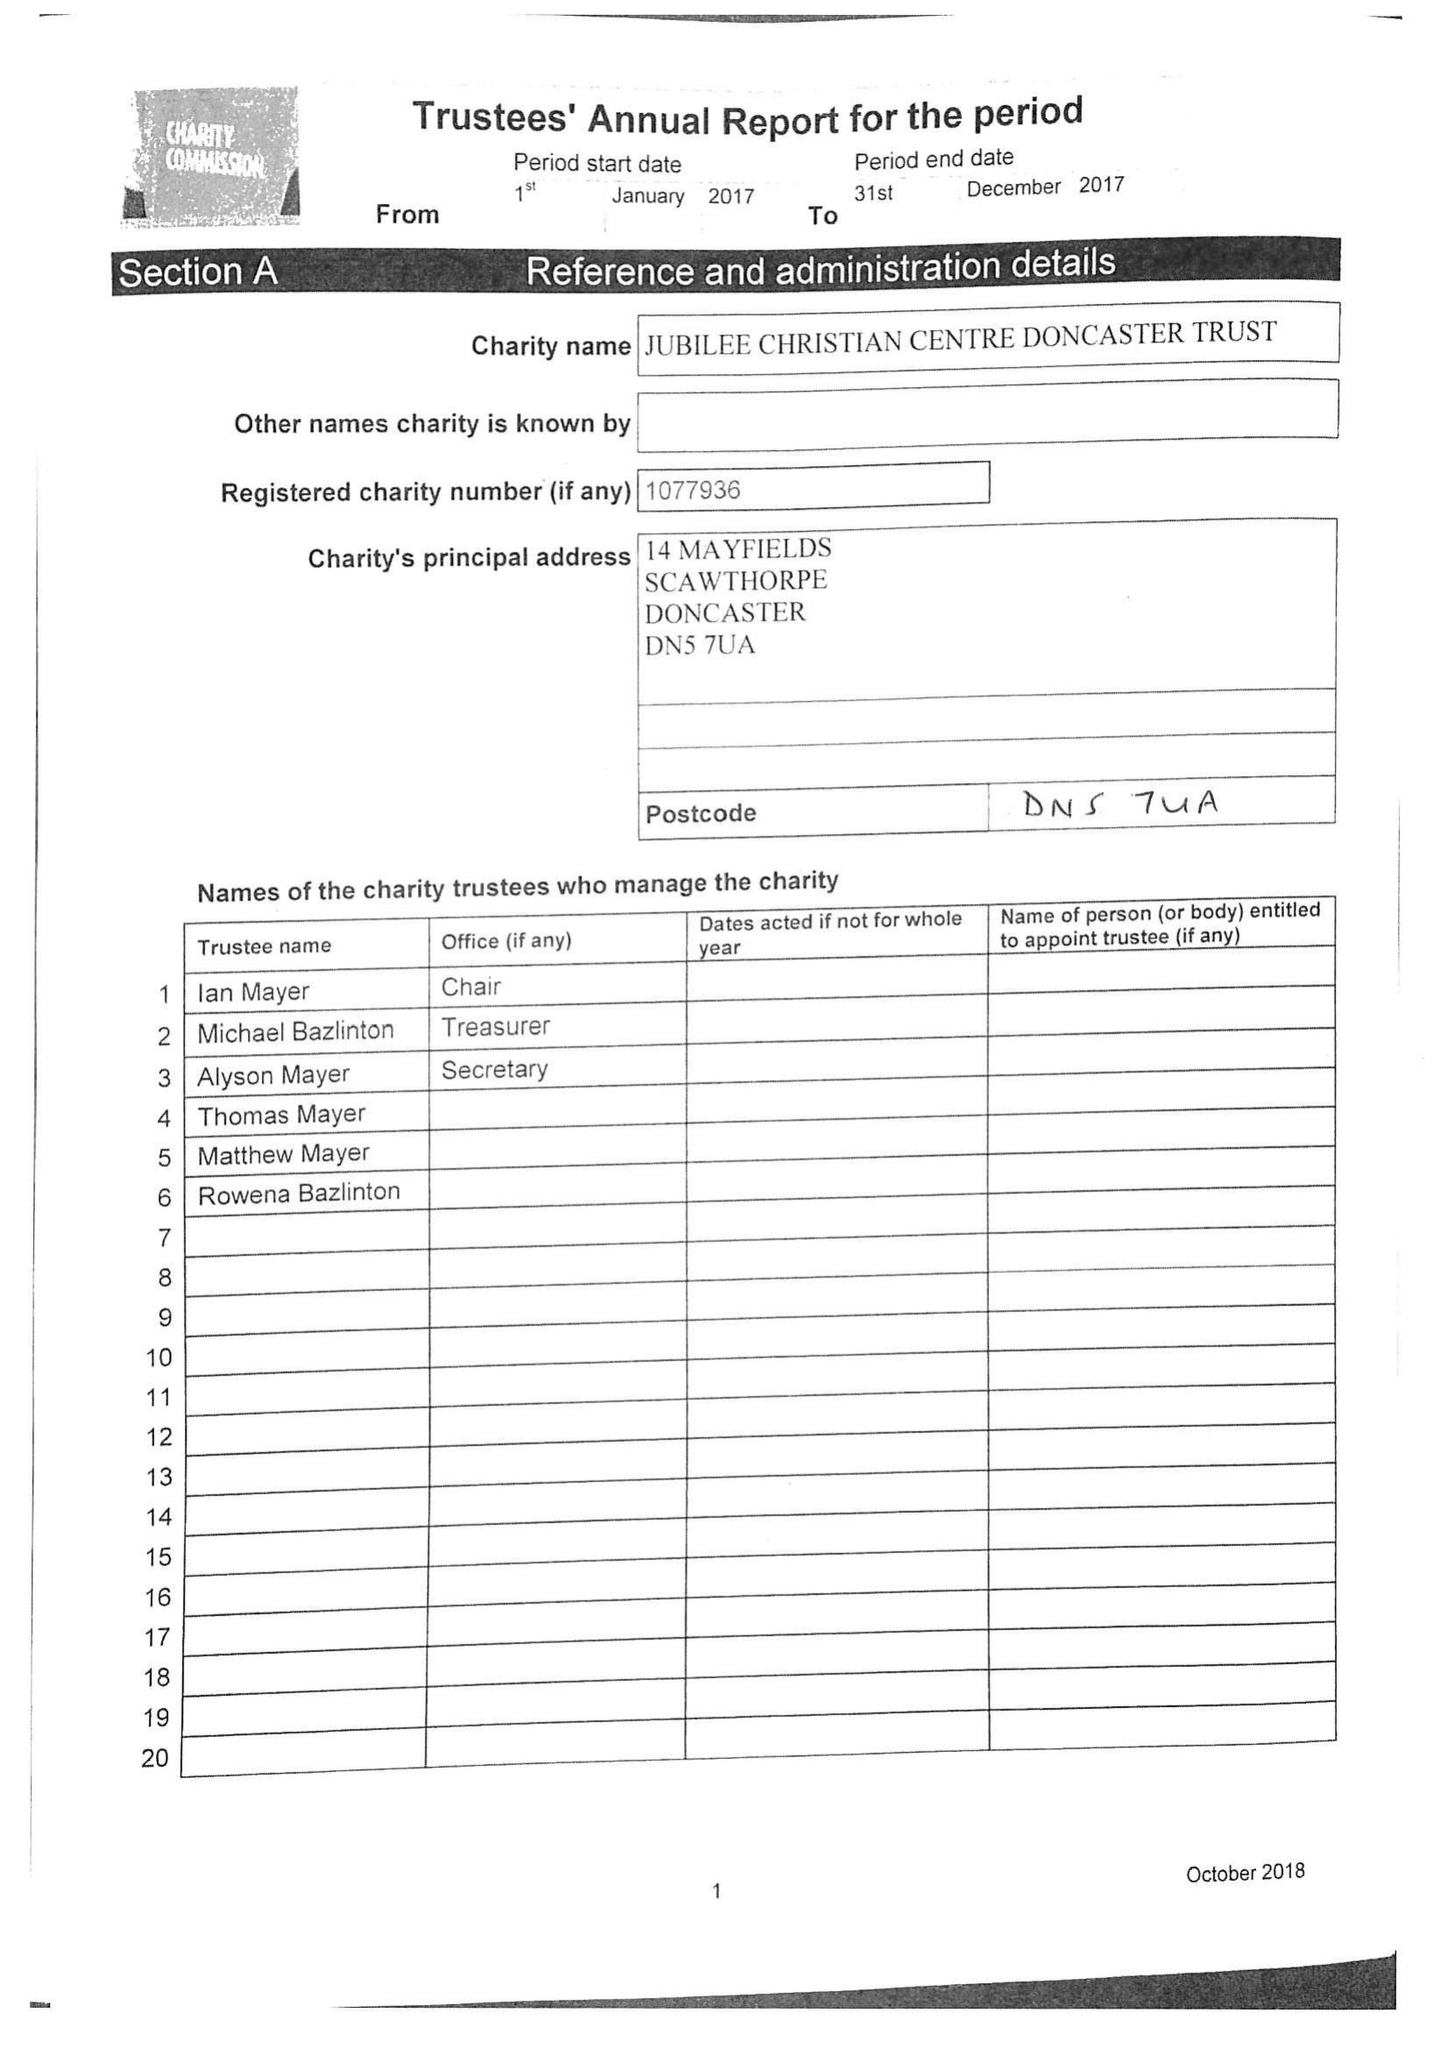What is the value for the charity_number?
Answer the question using a single word or phrase. 1077936 